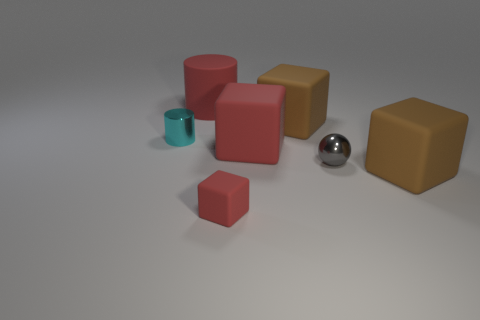Add 1 brown rubber spheres. How many objects exist? 8 Subtract all purple cubes. Subtract all green cylinders. How many cubes are left? 4 Subtract all cubes. How many objects are left? 3 Subtract all gray matte cylinders. Subtract all red cylinders. How many objects are left? 6 Add 1 large red rubber cylinders. How many large red rubber cylinders are left? 2 Add 5 brown cubes. How many brown cubes exist? 7 Subtract 0 cyan balls. How many objects are left? 7 